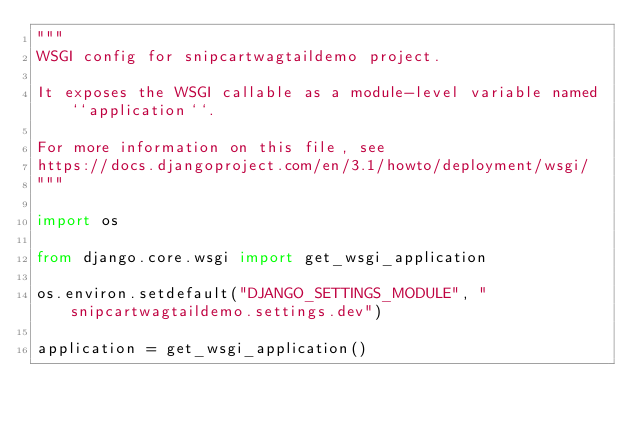Convert code to text. <code><loc_0><loc_0><loc_500><loc_500><_Python_>"""
WSGI config for snipcartwagtaildemo project.

It exposes the WSGI callable as a module-level variable named ``application``.

For more information on this file, see
https://docs.djangoproject.com/en/3.1/howto/deployment/wsgi/
"""

import os

from django.core.wsgi import get_wsgi_application

os.environ.setdefault("DJANGO_SETTINGS_MODULE", "snipcartwagtaildemo.settings.dev")

application = get_wsgi_application()
</code> 